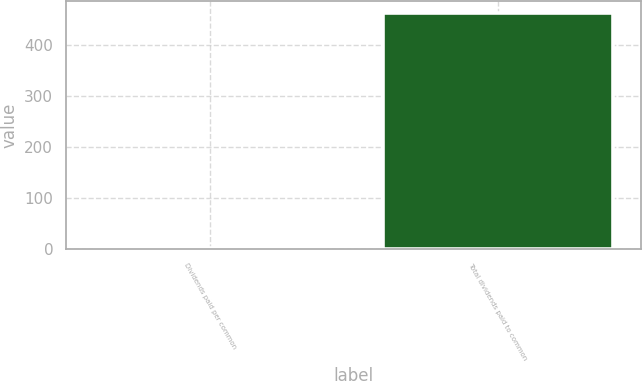Convert chart. <chart><loc_0><loc_0><loc_500><loc_500><bar_chart><fcel>Dividends paid per common<fcel>Total dividends paid to common<nl><fcel>1.22<fcel>462<nl></chart> 